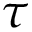<formula> <loc_0><loc_0><loc_500><loc_500>\tau</formula> 